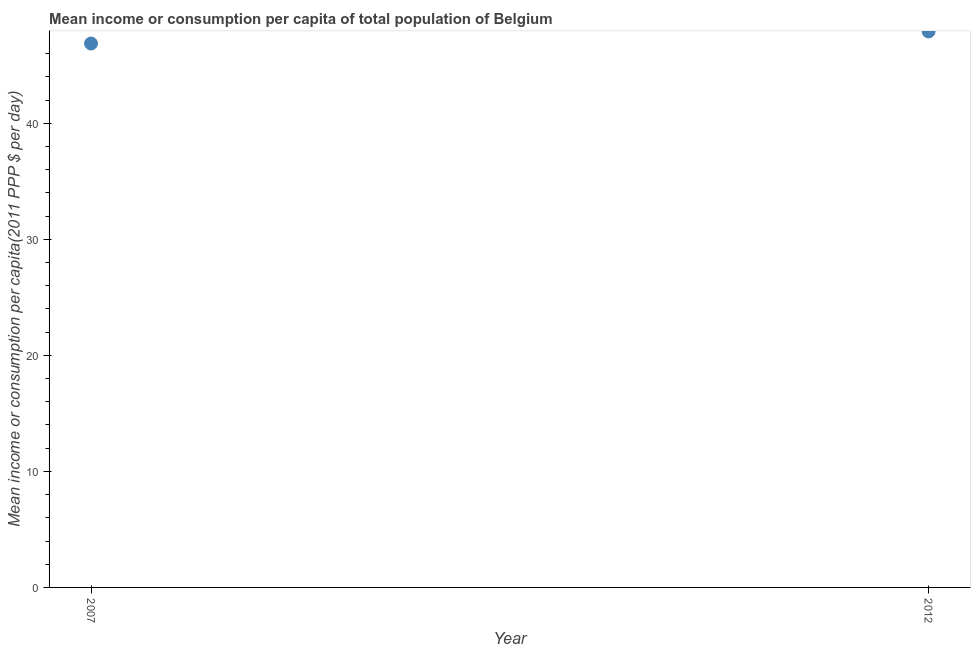What is the mean income or consumption in 2007?
Give a very brief answer. 46.88. Across all years, what is the maximum mean income or consumption?
Ensure brevity in your answer.  47.92. Across all years, what is the minimum mean income or consumption?
Provide a short and direct response. 46.88. In which year was the mean income or consumption maximum?
Your answer should be compact. 2012. In which year was the mean income or consumption minimum?
Keep it short and to the point. 2007. What is the sum of the mean income or consumption?
Your response must be concise. 94.8. What is the difference between the mean income or consumption in 2007 and 2012?
Provide a short and direct response. -1.04. What is the average mean income or consumption per year?
Make the answer very short. 47.4. What is the median mean income or consumption?
Your answer should be very brief. 47.4. In how many years, is the mean income or consumption greater than 22 $?
Keep it short and to the point. 2. What is the ratio of the mean income or consumption in 2007 to that in 2012?
Provide a succinct answer. 0.98. Does the mean income or consumption monotonically increase over the years?
Make the answer very short. Yes. How many years are there in the graph?
Offer a very short reply. 2. Does the graph contain any zero values?
Your answer should be compact. No. What is the title of the graph?
Your response must be concise. Mean income or consumption per capita of total population of Belgium. What is the label or title of the X-axis?
Ensure brevity in your answer.  Year. What is the label or title of the Y-axis?
Your answer should be very brief. Mean income or consumption per capita(2011 PPP $ per day). What is the Mean income or consumption per capita(2011 PPP $ per day) in 2007?
Your answer should be very brief. 46.88. What is the Mean income or consumption per capita(2011 PPP $ per day) in 2012?
Your answer should be very brief. 47.92. What is the difference between the Mean income or consumption per capita(2011 PPP $ per day) in 2007 and 2012?
Your answer should be very brief. -1.04. 